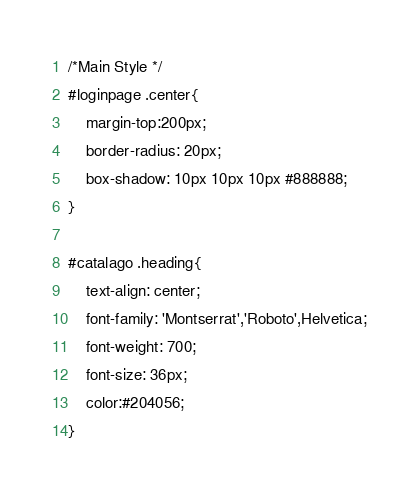<code> <loc_0><loc_0><loc_500><loc_500><_CSS_>/*Main Style */
#loginpage .center{
	margin-top:200px;
	border-radius: 20px;
	box-shadow: 10px 10px 10px #888888;
}

#catalago .heading{
    text-align: center;
    font-family: 'Montserrat','Roboto',Helvetica;
    font-weight: 700;
    font-size: 36px;
    color:#204056;
}</code> 